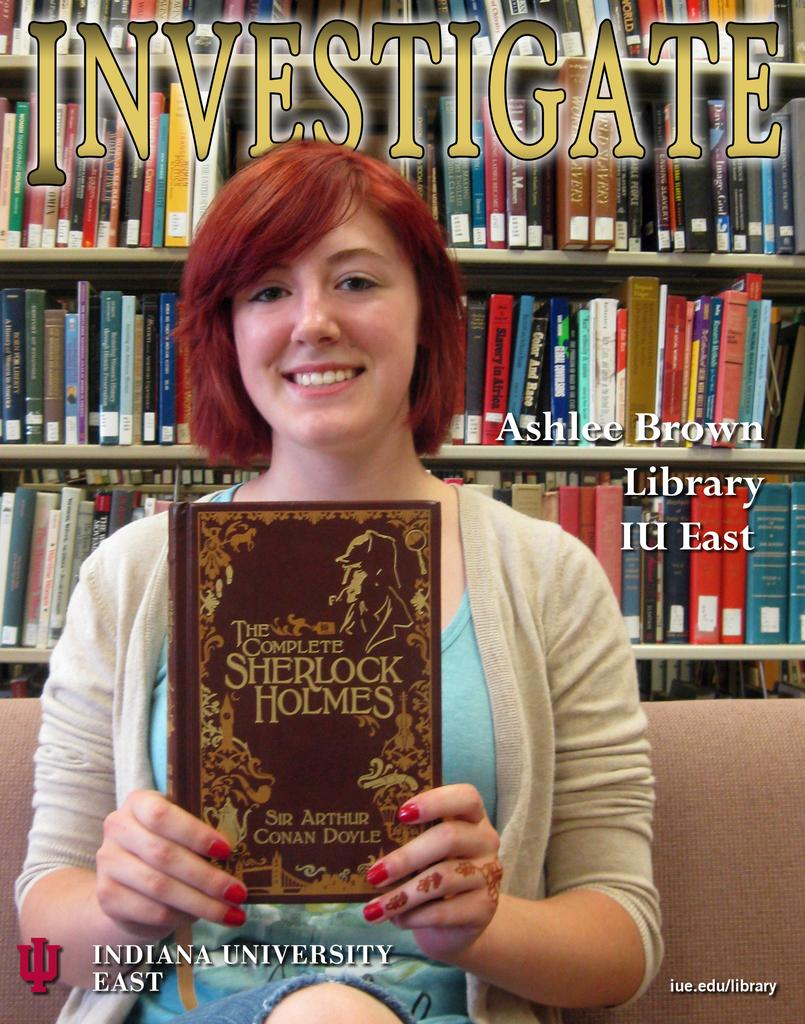<image>
Relay a brief, clear account of the picture shown. Indiana University East logo with The Complete Sherlock Holmes book. 